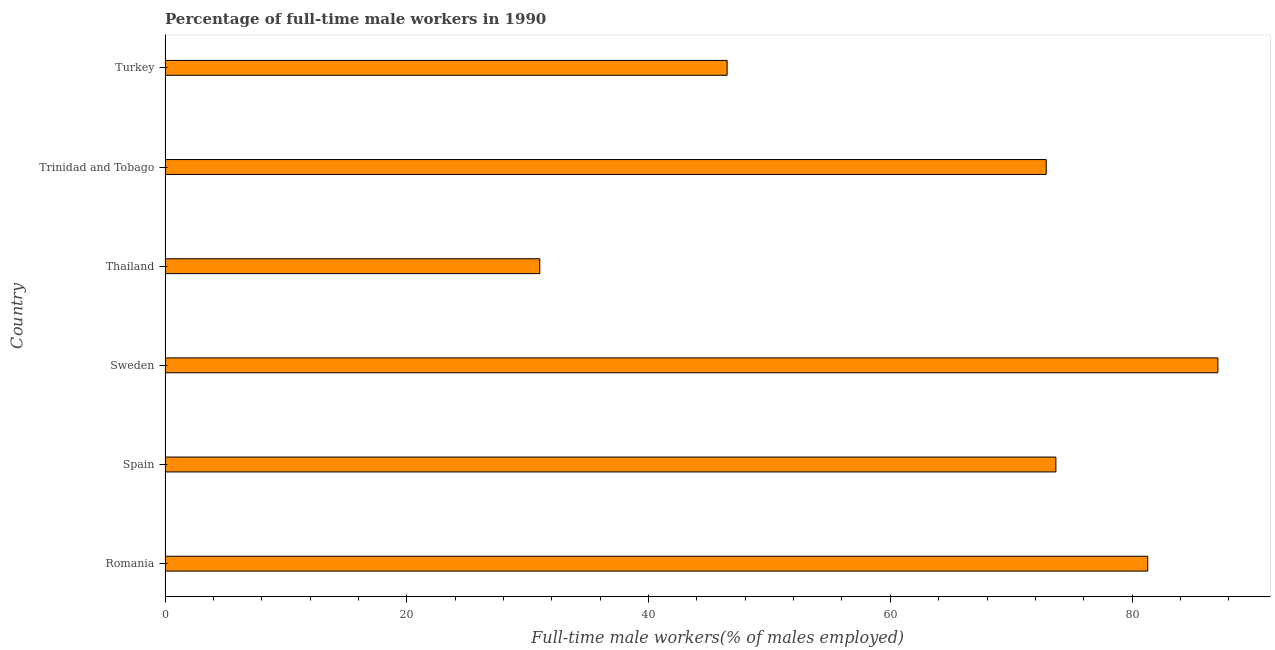Does the graph contain any zero values?
Offer a very short reply. No. What is the title of the graph?
Ensure brevity in your answer.  Percentage of full-time male workers in 1990. What is the label or title of the X-axis?
Your answer should be very brief. Full-time male workers(% of males employed). What is the percentage of full-time male workers in Turkey?
Make the answer very short. 46.5. Across all countries, what is the maximum percentage of full-time male workers?
Make the answer very short. 87.1. Across all countries, what is the minimum percentage of full-time male workers?
Offer a very short reply. 31. In which country was the percentage of full-time male workers maximum?
Ensure brevity in your answer.  Sweden. In which country was the percentage of full-time male workers minimum?
Give a very brief answer. Thailand. What is the sum of the percentage of full-time male workers?
Provide a succinct answer. 392.5. What is the difference between the percentage of full-time male workers in Sweden and Turkey?
Keep it short and to the point. 40.6. What is the average percentage of full-time male workers per country?
Make the answer very short. 65.42. What is the median percentage of full-time male workers?
Your response must be concise. 73.3. What is the ratio of the percentage of full-time male workers in Romania to that in Sweden?
Give a very brief answer. 0.93. Is the percentage of full-time male workers in Spain less than that in Trinidad and Tobago?
Make the answer very short. No. Is the difference between the percentage of full-time male workers in Romania and Trinidad and Tobago greater than the difference between any two countries?
Your answer should be compact. No. What is the difference between the highest and the second highest percentage of full-time male workers?
Your answer should be compact. 5.8. Is the sum of the percentage of full-time male workers in Sweden and Trinidad and Tobago greater than the maximum percentage of full-time male workers across all countries?
Give a very brief answer. Yes. What is the difference between the highest and the lowest percentage of full-time male workers?
Provide a succinct answer. 56.1. How many bars are there?
Give a very brief answer. 6. How many countries are there in the graph?
Provide a succinct answer. 6. What is the difference between two consecutive major ticks on the X-axis?
Provide a succinct answer. 20. What is the Full-time male workers(% of males employed) in Romania?
Ensure brevity in your answer.  81.3. What is the Full-time male workers(% of males employed) in Spain?
Your response must be concise. 73.7. What is the Full-time male workers(% of males employed) in Sweden?
Make the answer very short. 87.1. What is the Full-time male workers(% of males employed) of Trinidad and Tobago?
Your answer should be compact. 72.9. What is the Full-time male workers(% of males employed) of Turkey?
Provide a succinct answer. 46.5. What is the difference between the Full-time male workers(% of males employed) in Romania and Spain?
Your answer should be very brief. 7.6. What is the difference between the Full-time male workers(% of males employed) in Romania and Sweden?
Offer a very short reply. -5.8. What is the difference between the Full-time male workers(% of males employed) in Romania and Thailand?
Your answer should be compact. 50.3. What is the difference between the Full-time male workers(% of males employed) in Romania and Trinidad and Tobago?
Ensure brevity in your answer.  8.4. What is the difference between the Full-time male workers(% of males employed) in Romania and Turkey?
Keep it short and to the point. 34.8. What is the difference between the Full-time male workers(% of males employed) in Spain and Thailand?
Give a very brief answer. 42.7. What is the difference between the Full-time male workers(% of males employed) in Spain and Trinidad and Tobago?
Make the answer very short. 0.8. What is the difference between the Full-time male workers(% of males employed) in Spain and Turkey?
Keep it short and to the point. 27.2. What is the difference between the Full-time male workers(% of males employed) in Sweden and Thailand?
Offer a very short reply. 56.1. What is the difference between the Full-time male workers(% of males employed) in Sweden and Trinidad and Tobago?
Offer a very short reply. 14.2. What is the difference between the Full-time male workers(% of males employed) in Sweden and Turkey?
Your answer should be compact. 40.6. What is the difference between the Full-time male workers(% of males employed) in Thailand and Trinidad and Tobago?
Provide a short and direct response. -41.9. What is the difference between the Full-time male workers(% of males employed) in Thailand and Turkey?
Your answer should be very brief. -15.5. What is the difference between the Full-time male workers(% of males employed) in Trinidad and Tobago and Turkey?
Provide a succinct answer. 26.4. What is the ratio of the Full-time male workers(% of males employed) in Romania to that in Spain?
Provide a short and direct response. 1.1. What is the ratio of the Full-time male workers(% of males employed) in Romania to that in Sweden?
Your answer should be compact. 0.93. What is the ratio of the Full-time male workers(% of males employed) in Romania to that in Thailand?
Offer a terse response. 2.62. What is the ratio of the Full-time male workers(% of males employed) in Romania to that in Trinidad and Tobago?
Keep it short and to the point. 1.11. What is the ratio of the Full-time male workers(% of males employed) in Romania to that in Turkey?
Provide a succinct answer. 1.75. What is the ratio of the Full-time male workers(% of males employed) in Spain to that in Sweden?
Your answer should be very brief. 0.85. What is the ratio of the Full-time male workers(% of males employed) in Spain to that in Thailand?
Your response must be concise. 2.38. What is the ratio of the Full-time male workers(% of males employed) in Spain to that in Turkey?
Keep it short and to the point. 1.58. What is the ratio of the Full-time male workers(% of males employed) in Sweden to that in Thailand?
Give a very brief answer. 2.81. What is the ratio of the Full-time male workers(% of males employed) in Sweden to that in Trinidad and Tobago?
Make the answer very short. 1.2. What is the ratio of the Full-time male workers(% of males employed) in Sweden to that in Turkey?
Your answer should be compact. 1.87. What is the ratio of the Full-time male workers(% of males employed) in Thailand to that in Trinidad and Tobago?
Your response must be concise. 0.42. What is the ratio of the Full-time male workers(% of males employed) in Thailand to that in Turkey?
Offer a terse response. 0.67. What is the ratio of the Full-time male workers(% of males employed) in Trinidad and Tobago to that in Turkey?
Your answer should be very brief. 1.57. 